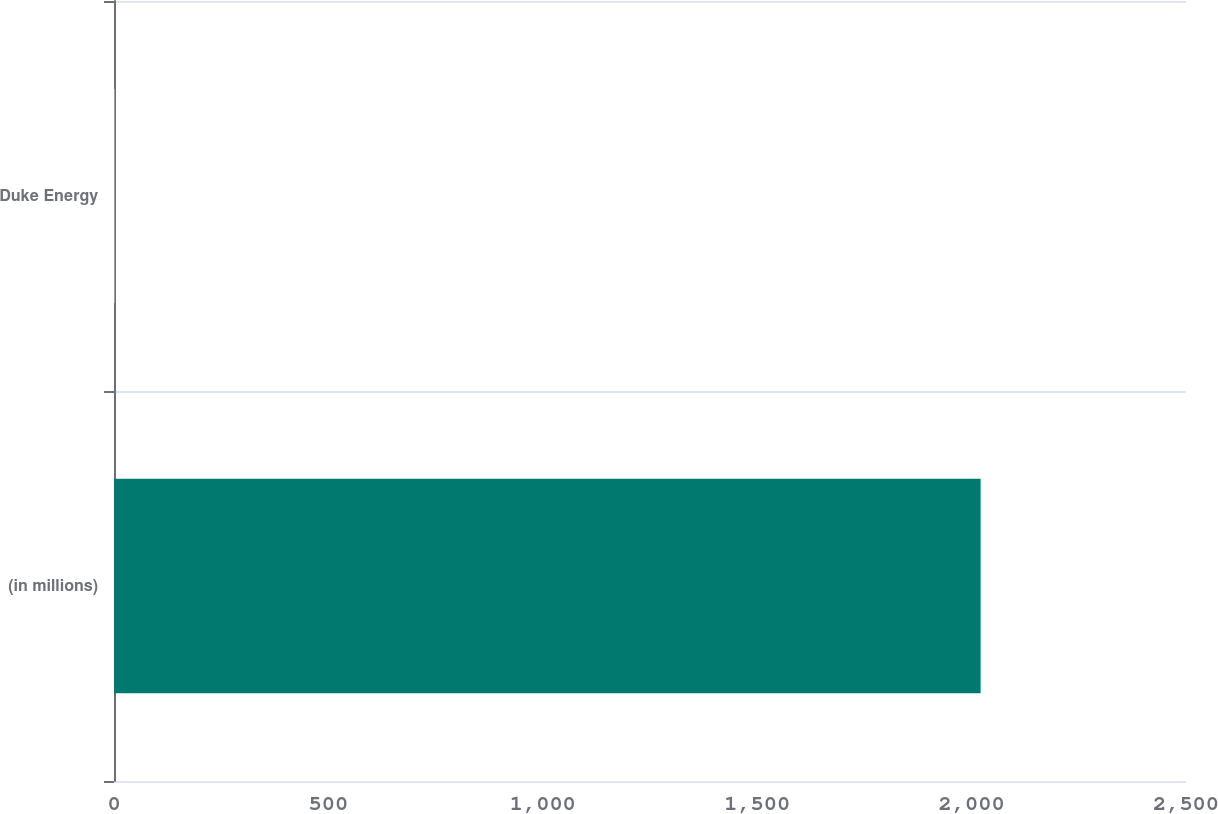Convert chart. <chart><loc_0><loc_0><loc_500><loc_500><bar_chart><fcel>(in millions)<fcel>Duke Energy<nl><fcel>2021<fcel>2<nl></chart> 